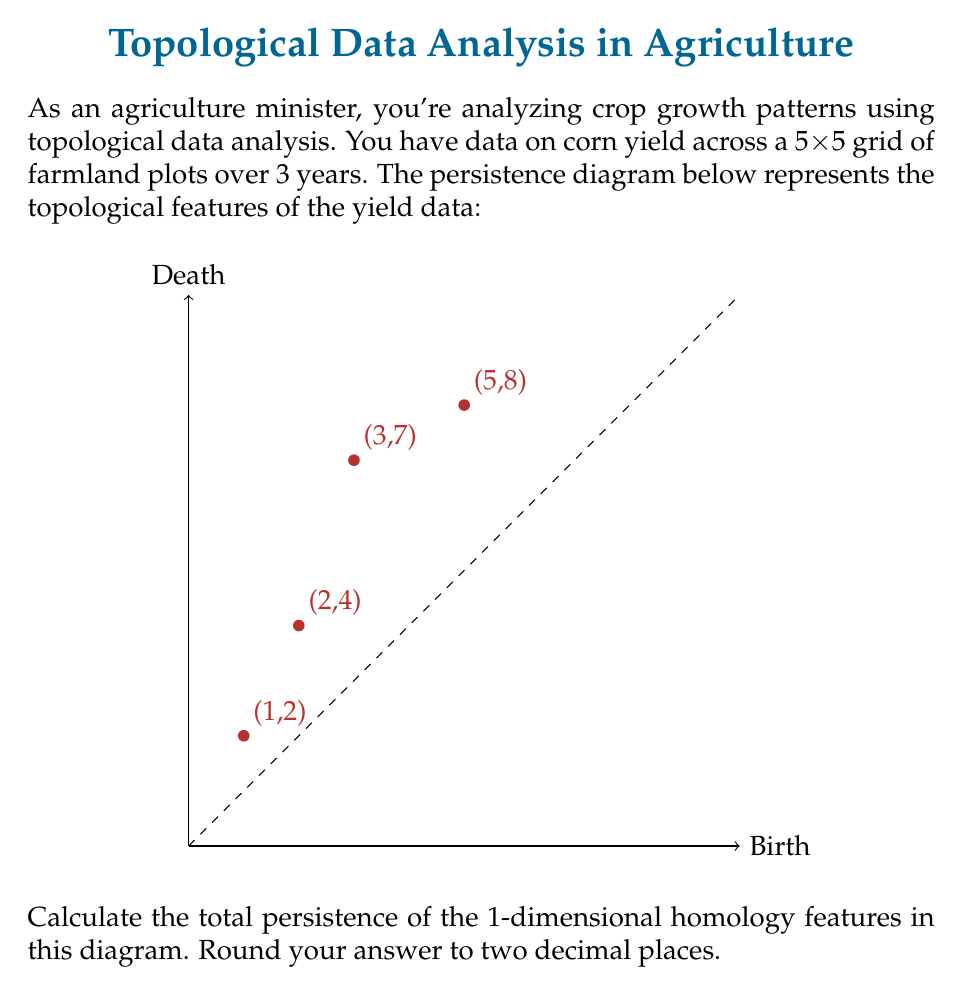What is the answer to this math problem? To solve this problem, we need to follow these steps:

1) Understand what the persistence diagram represents:
   - Each point (b,d) in the diagram represents a topological feature.
   - b is the "birth" time of the feature, and d is its "death" time.
   - The vertical distance from a point to the diagonal line y=x represents the lifespan of that feature.

2) Identify the 1-dimensional homology features:
   - All points in this diagram represent 1-dimensional features (loops or holes in the data).

3) Calculate the persistence of each feature:
   - Persistence is defined as (death - birth)
   - For (1,2): persistence = 2 - 1 = 1
   - For (2,4): persistence = 4 - 2 = 2
   - For (3,7): persistence = 7 - 3 = 4
   - For (5,8): persistence = 8 - 5 = 3

4) Sum up all the persistence values:
   $$ \text{Total Persistence} = 1 + 2 + 4 + 3 = 10 $$

5) Round to two decimal places:
   10.00

The total persistence gives us a measure of the stability and significance of the topological features in our crop yield data. A higher total persistence suggests more prominent and long-lasting patterns in the yield variations across the farmland and over time.
Answer: 10.00 